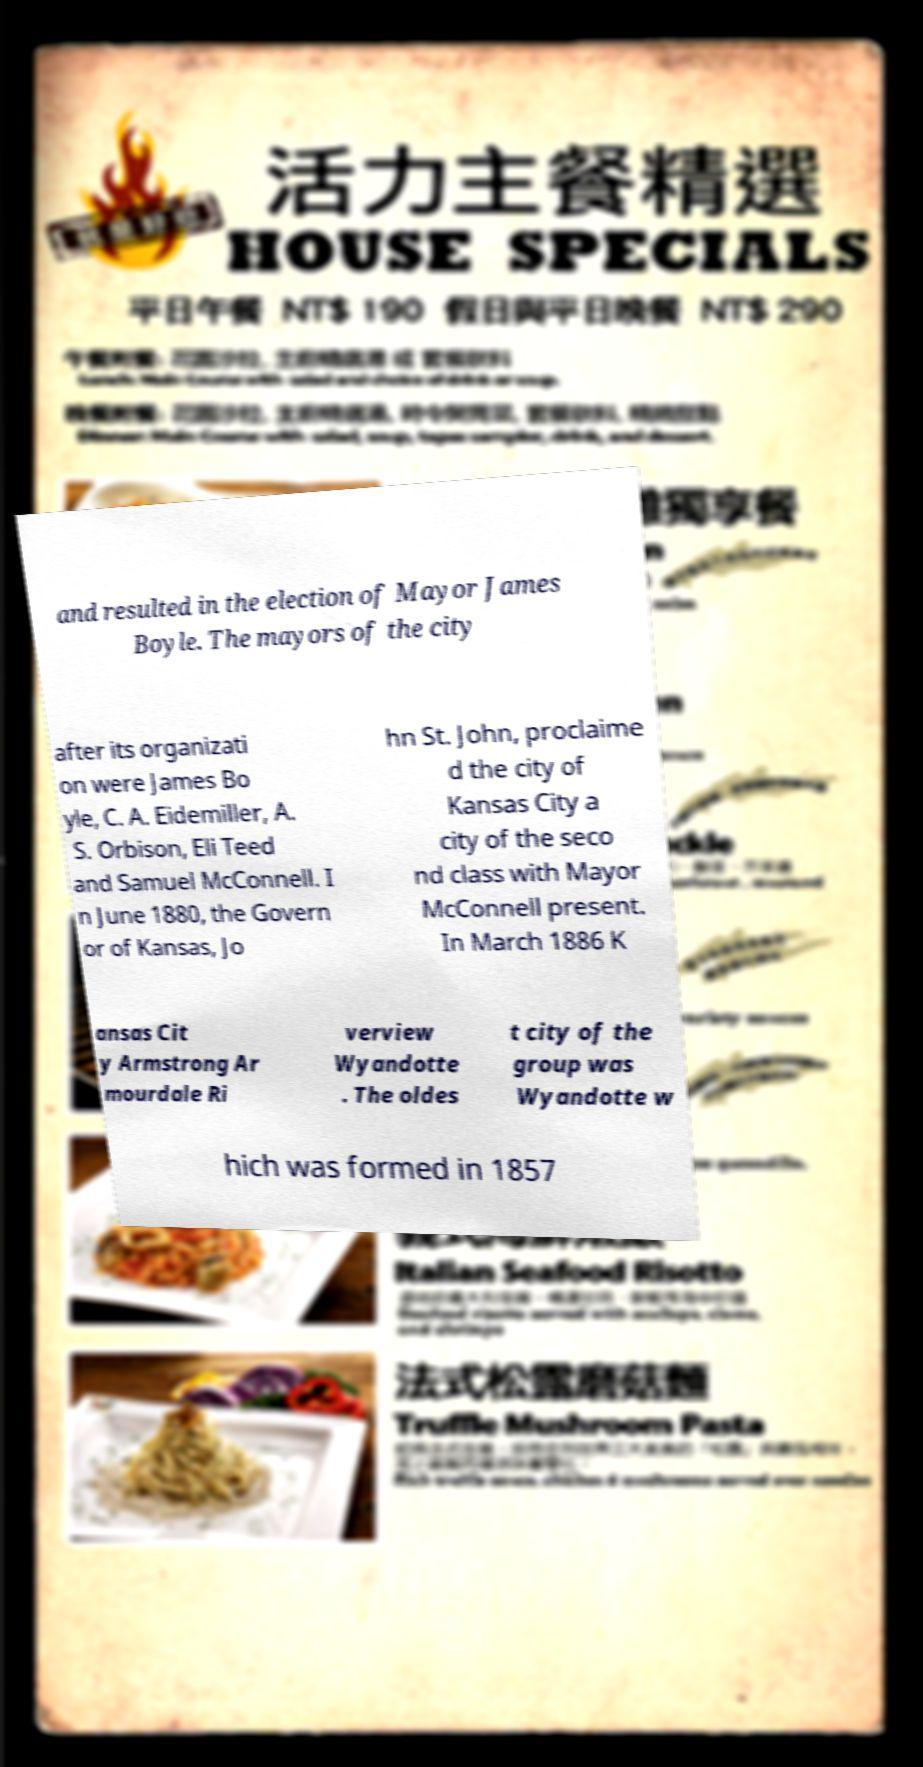Can you read and provide the text displayed in the image?This photo seems to have some interesting text. Can you extract and type it out for me? and resulted in the election of Mayor James Boyle. The mayors of the city after its organizati on were James Bo yle, C. A. Eidemiller, A. S. Orbison, Eli Teed and Samuel McConnell. I n June 1880, the Govern or of Kansas, Jo hn St. John, proclaime d the city of Kansas City a city of the seco nd class with Mayor McConnell present. In March 1886 K ansas Cit y Armstrong Ar mourdale Ri verview Wyandotte . The oldes t city of the group was Wyandotte w hich was formed in 1857 